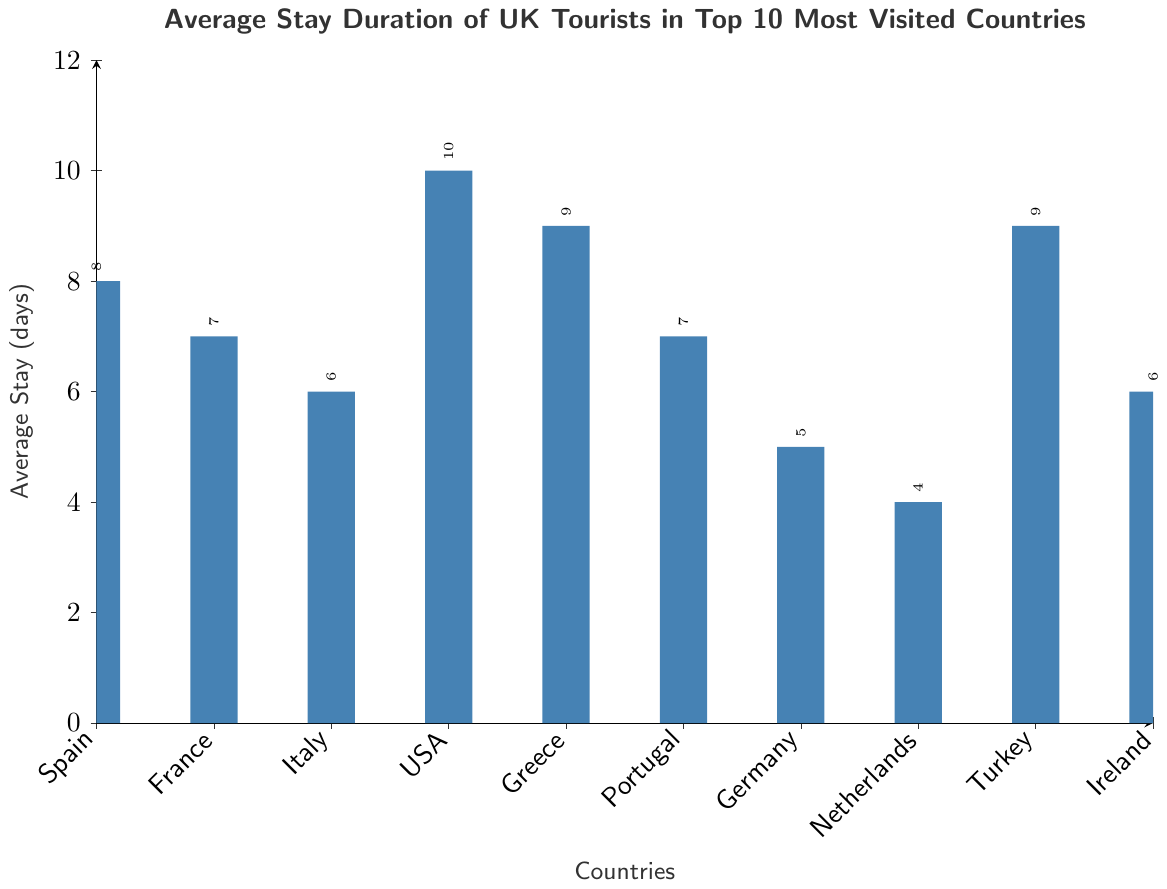What's the average stay duration for UK tourists in the USA? Look for the bar representing the USA and read the value on the y-axis.
Answer: 10 days Which country has the shortest average stay duration? By comparing all the bars visually, the shortest bar is for the Netherlands.
Answer: Netherlands How many countries have an average stay duration of 7 days? Locate and count the bars that reach up to the 7-day mark on the y-axis: France and Portugal.
Answer: 2 Which countries have an average stay duration greater than or equal to 8 days? Identify all the bars that are equal to or taller than 8 on the y-axis: Spain, USA, Greece, Turkey.
Answer: 4 What is the total average stay duration for the top 5 most visited countries? Locate the top 5 countries: Spain (8), France (7), Italy (6), USA (10), Greece (9). Sum their values: 8 + 7 + 6 + 10 + 9 = 40 days.
Answer: 40 days Is the average stay duration greater in Turkey or Ireland? Compare the heights of the bars for Turkey and Ireland. Turkey's is taller.
Answer: Turkey What is the difference in average stay duration between Spain and Germany? Find the bar heights for Spain and Germany: Spain is 8 days, Germany is 5 days. Calculate the difference: 8 - 5 = 3 days.
Answer: 3 days If the average stay duration for the Netherlands increased by 2 days, what would it be? The current duration is 4 days. Add 2 days: 4 + 2 = 6 days.
Answer: 6 days Which two countries have an equal average stay duration? Identify countries with bars of the same height: France and Portugal both have 7 days.
Answer: France and Portugal 